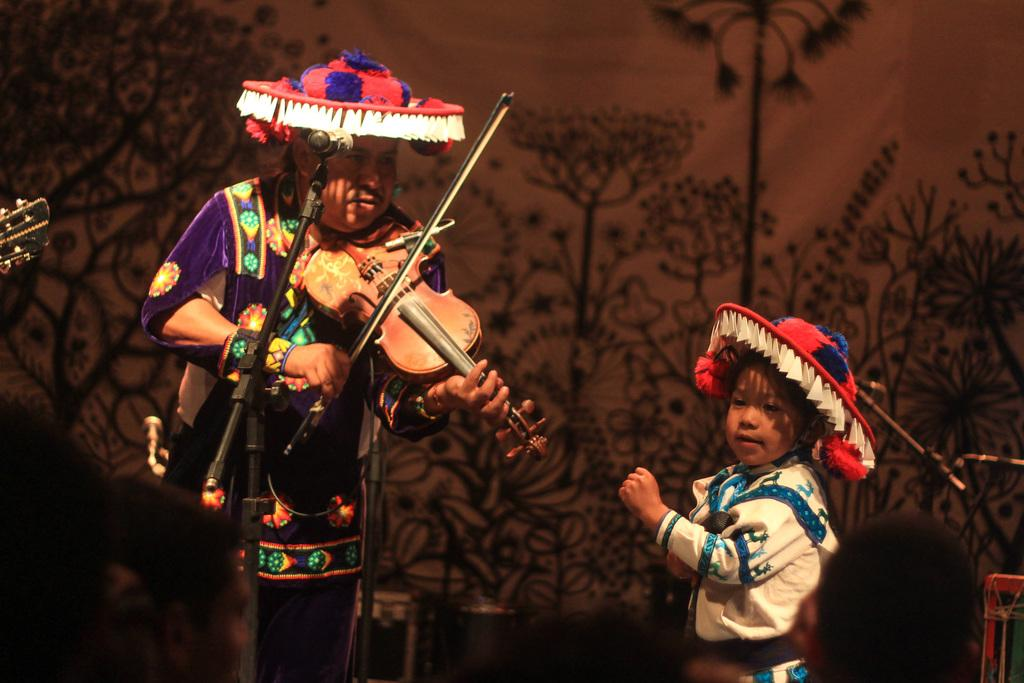Who are the people in the image? There is a man and a girl in the image. What is the man holding in the image? The man is holding a musical instrument. What are the people wearing on their heads? Both the man and the girl are wearing hats. What object is in front of the man? There is a microphone (mic) in front of the man. What type of bread is the man eating in the image? There is no bread present in the image. 